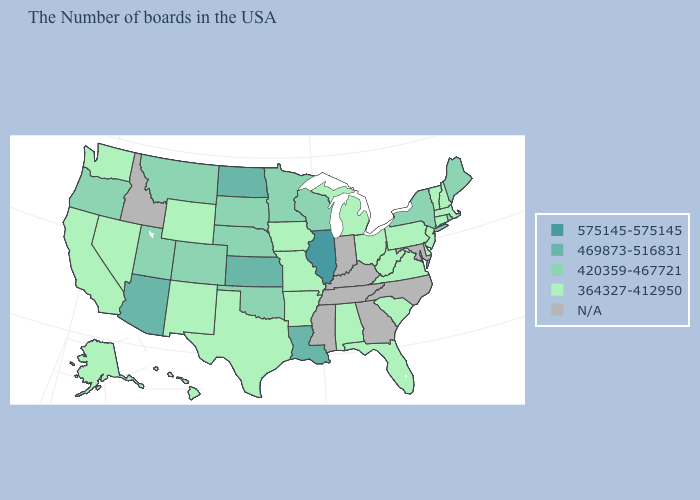Does the map have missing data?
Write a very short answer. Yes. What is the lowest value in the USA?
Give a very brief answer. 364327-412950. Which states have the lowest value in the West?
Be succinct. Wyoming, New Mexico, Nevada, California, Washington, Alaska, Hawaii. What is the value of California?
Write a very short answer. 364327-412950. Does South Dakota have the lowest value in the USA?
Write a very short answer. No. What is the value of Texas?
Short answer required. 364327-412950. Which states have the lowest value in the USA?
Quick response, please. Massachusetts, New Hampshire, Vermont, Connecticut, New Jersey, Delaware, Pennsylvania, Virginia, South Carolina, West Virginia, Ohio, Florida, Michigan, Alabama, Missouri, Arkansas, Iowa, Texas, Wyoming, New Mexico, Nevada, California, Washington, Alaska, Hawaii. What is the value of New York?
Write a very short answer. 420359-467721. Does the map have missing data?
Keep it brief. Yes. What is the value of Pennsylvania?
Quick response, please. 364327-412950. Which states have the lowest value in the USA?
Give a very brief answer. Massachusetts, New Hampshire, Vermont, Connecticut, New Jersey, Delaware, Pennsylvania, Virginia, South Carolina, West Virginia, Ohio, Florida, Michigan, Alabama, Missouri, Arkansas, Iowa, Texas, Wyoming, New Mexico, Nevada, California, Washington, Alaska, Hawaii. What is the value of Ohio?
Give a very brief answer. 364327-412950. Does Nebraska have the lowest value in the USA?
Give a very brief answer. No. Name the states that have a value in the range 469873-516831?
Write a very short answer. Louisiana, Kansas, North Dakota, Arizona. 